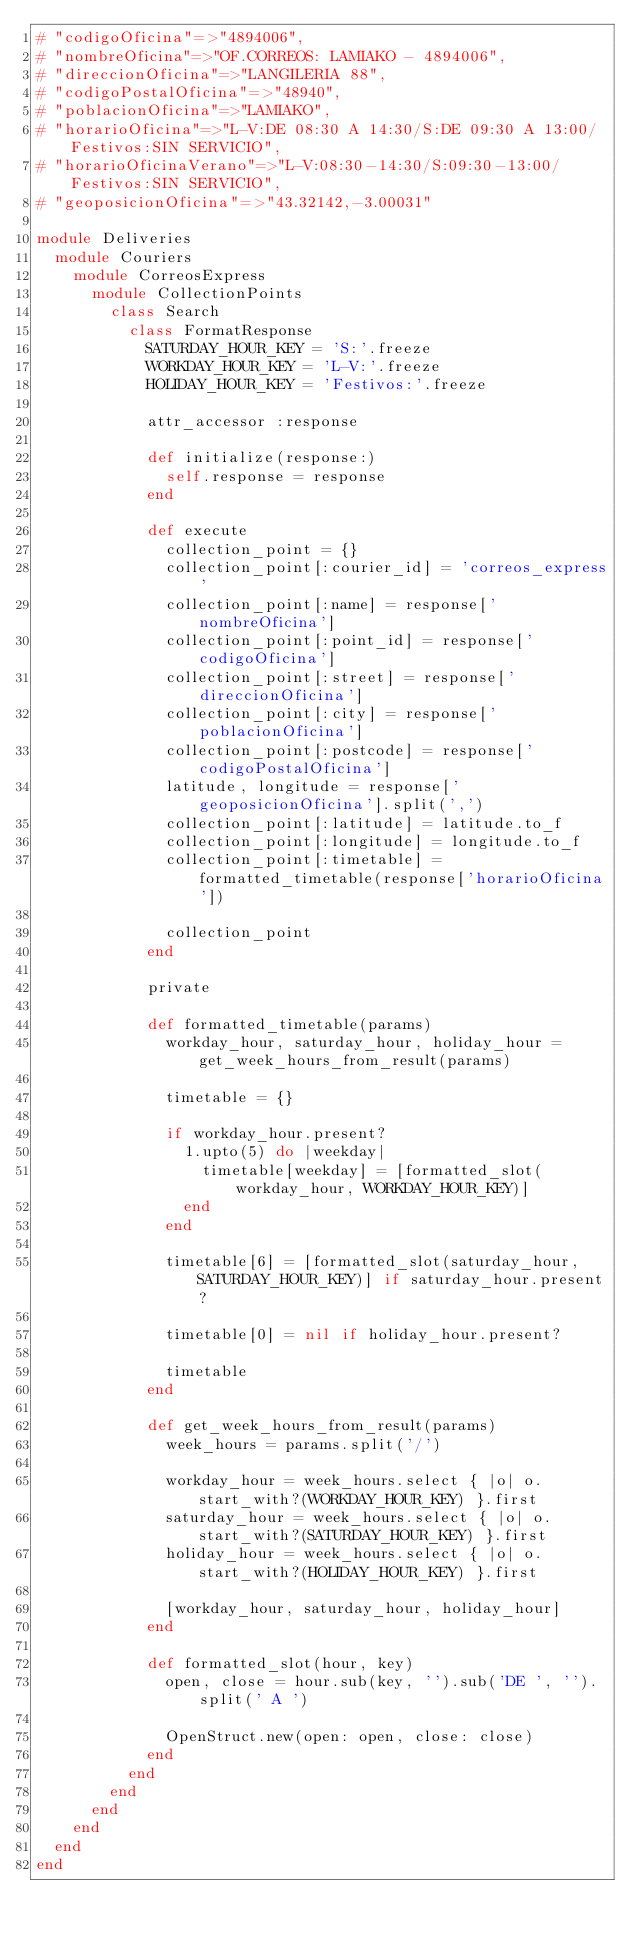Convert code to text. <code><loc_0><loc_0><loc_500><loc_500><_Ruby_># "codigoOficina"=>"4894006",
# "nombreOficina"=>"OF.CORREOS: LAMIAKO - 4894006",
# "direccionOficina"=>"LANGILERIA 88",
# "codigoPostalOficina"=>"48940",
# "poblacionOficina"=>"LAMIAKO",
# "horarioOficina"=>"L-V:DE 08:30 A 14:30/S:DE 09:30 A 13:00/Festivos:SIN SERVICIO",
# "horarioOficinaVerano"=>"L-V:08:30-14:30/S:09:30-13:00/Festivos:SIN SERVICIO",
# "geoposicionOficina"=>"43.32142,-3.00031"

module Deliveries
  module Couriers
    module CorreosExpress
      module CollectionPoints
        class Search
          class FormatResponse
            SATURDAY_HOUR_KEY = 'S:'.freeze
            WORKDAY_HOUR_KEY = 'L-V:'.freeze
            HOLIDAY_HOUR_KEY = 'Festivos:'.freeze

            attr_accessor :response

            def initialize(response:)
              self.response = response
            end

            def execute
              collection_point = {}
              collection_point[:courier_id] = 'correos_express'
              collection_point[:name] = response['nombreOficina']
              collection_point[:point_id] = response['codigoOficina']
              collection_point[:street] = response['direccionOficina']
              collection_point[:city] = response['poblacionOficina']
              collection_point[:postcode] = response['codigoPostalOficina']
              latitude, longitude = response['geoposicionOficina'].split(',')
              collection_point[:latitude] = latitude.to_f
              collection_point[:longitude] = longitude.to_f
              collection_point[:timetable] = formatted_timetable(response['horarioOficina'])

              collection_point
            end

            private

            def formatted_timetable(params)
              workday_hour, saturday_hour, holiday_hour = get_week_hours_from_result(params)

              timetable = {}

              if workday_hour.present?
                1.upto(5) do |weekday|
                  timetable[weekday] = [formatted_slot(workday_hour, WORKDAY_HOUR_KEY)]
                end
              end

              timetable[6] = [formatted_slot(saturday_hour, SATURDAY_HOUR_KEY)] if saturday_hour.present?

              timetable[0] = nil if holiday_hour.present?

              timetable
            end

            def get_week_hours_from_result(params)
              week_hours = params.split('/')

              workday_hour = week_hours.select { |o| o.start_with?(WORKDAY_HOUR_KEY) }.first
              saturday_hour = week_hours.select { |o| o.start_with?(SATURDAY_HOUR_KEY) }.first
              holiday_hour = week_hours.select { |o| o.start_with?(HOLIDAY_HOUR_KEY) }.first

              [workday_hour, saturday_hour, holiday_hour]
            end

            def formatted_slot(hour, key)
              open, close = hour.sub(key, '').sub('DE ', '').split(' A ')

              OpenStruct.new(open: open, close: close)
            end
          end
        end
      end
    end
  end
end
</code> 